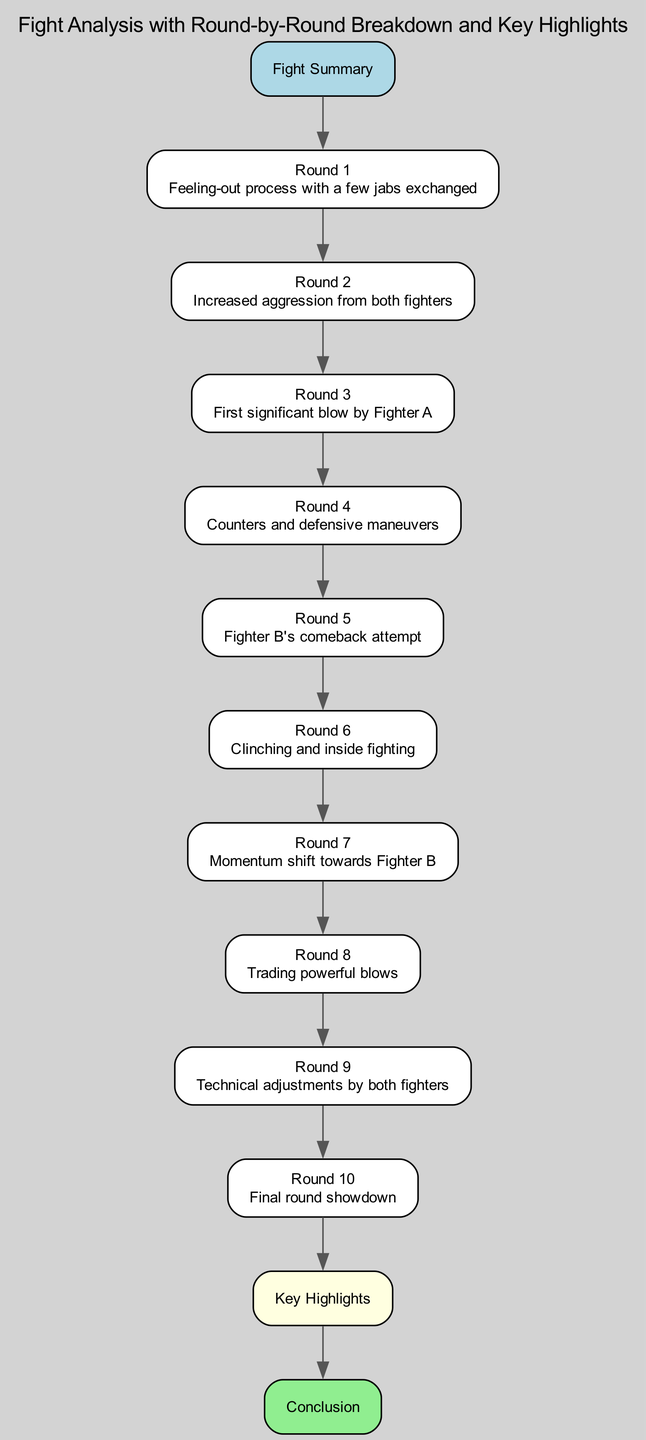What is the title of the diagram? The title of the diagram is indicated at the top and introduces the main topic being discussed, which is "Fight Analysis with Round-by-Round Breakdown and Key Highlights."
Answer: Fight Analysis with Round-by-Round Breakdown and Key Highlights How many rounds are described in the diagram? The diagram lists a total of ten rounds, each with specific details about the events that occurred during those rounds. The counting of nodes from "Round 1" to "Round 10" confirms this.
Answer: 10 What occurs in Round 5? The details state that "Fighter B's comeback attempt" takes place in Round 5, showcasing the specific action described for that round.
Answer: Fighter B's comeback attempt What is the key highlight at the end of the fight? The key highlights node summarizes "Turning points and standout moments" that were critical to understanding the fight's outcome. This node is connected to the Conclusion, indicating its importance.
Answer: Turning points and standout moments Which round marks the first significant blow by Fighter A? According to the details for each round, "First significant blow by Fighter A" is explicitly stated to occur in Round 3, indicating its specific placement in the sequence of events.
Answer: Round 3 What is the conclusion derived from the fight analysis? The conclusion node indicates that it provides "Final analysis and next steps," summarizing the outcomes and potential future implications based on the fight analysis presented.
Answer: Final analysis and next steps Which round features trading powerful blows? The diagram mentions that in Round 8, the fighters are "Trading powerful blows," indicating not only the nature of action in that round but also distinguishing it from others.
Answer: Round 8 Which round experienced a momentum shift? The notes specify that Round 7 represents a "Momentum shift towards Fighter B," indicating a change in the balance of the fight's control and direction.
Answer: Round 7 What is the purpose of the key highlights node? The key highlights node serves to provide a summary of significant moments and turning points during the fight, acting as a concise overview after the detailed breakdown of each round.
Answer: Summary of significant moments and turning points 